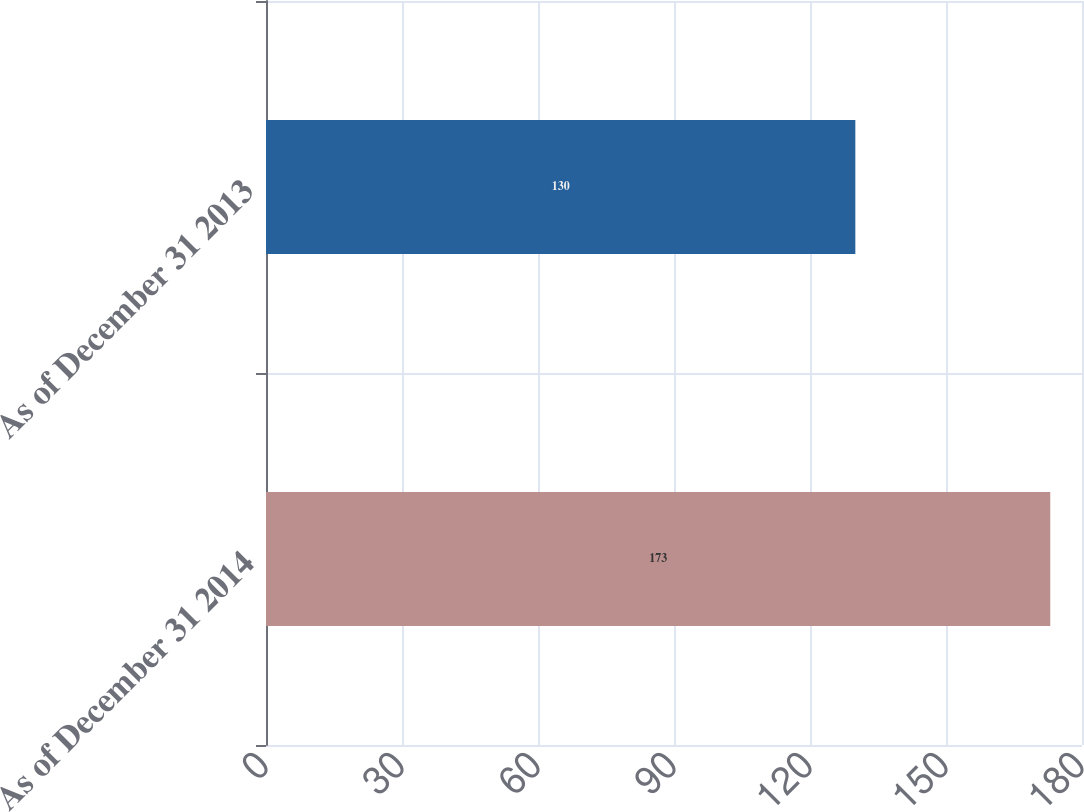<chart> <loc_0><loc_0><loc_500><loc_500><bar_chart><fcel>As of December 31 2014<fcel>As of December 31 2013<nl><fcel>173<fcel>130<nl></chart> 